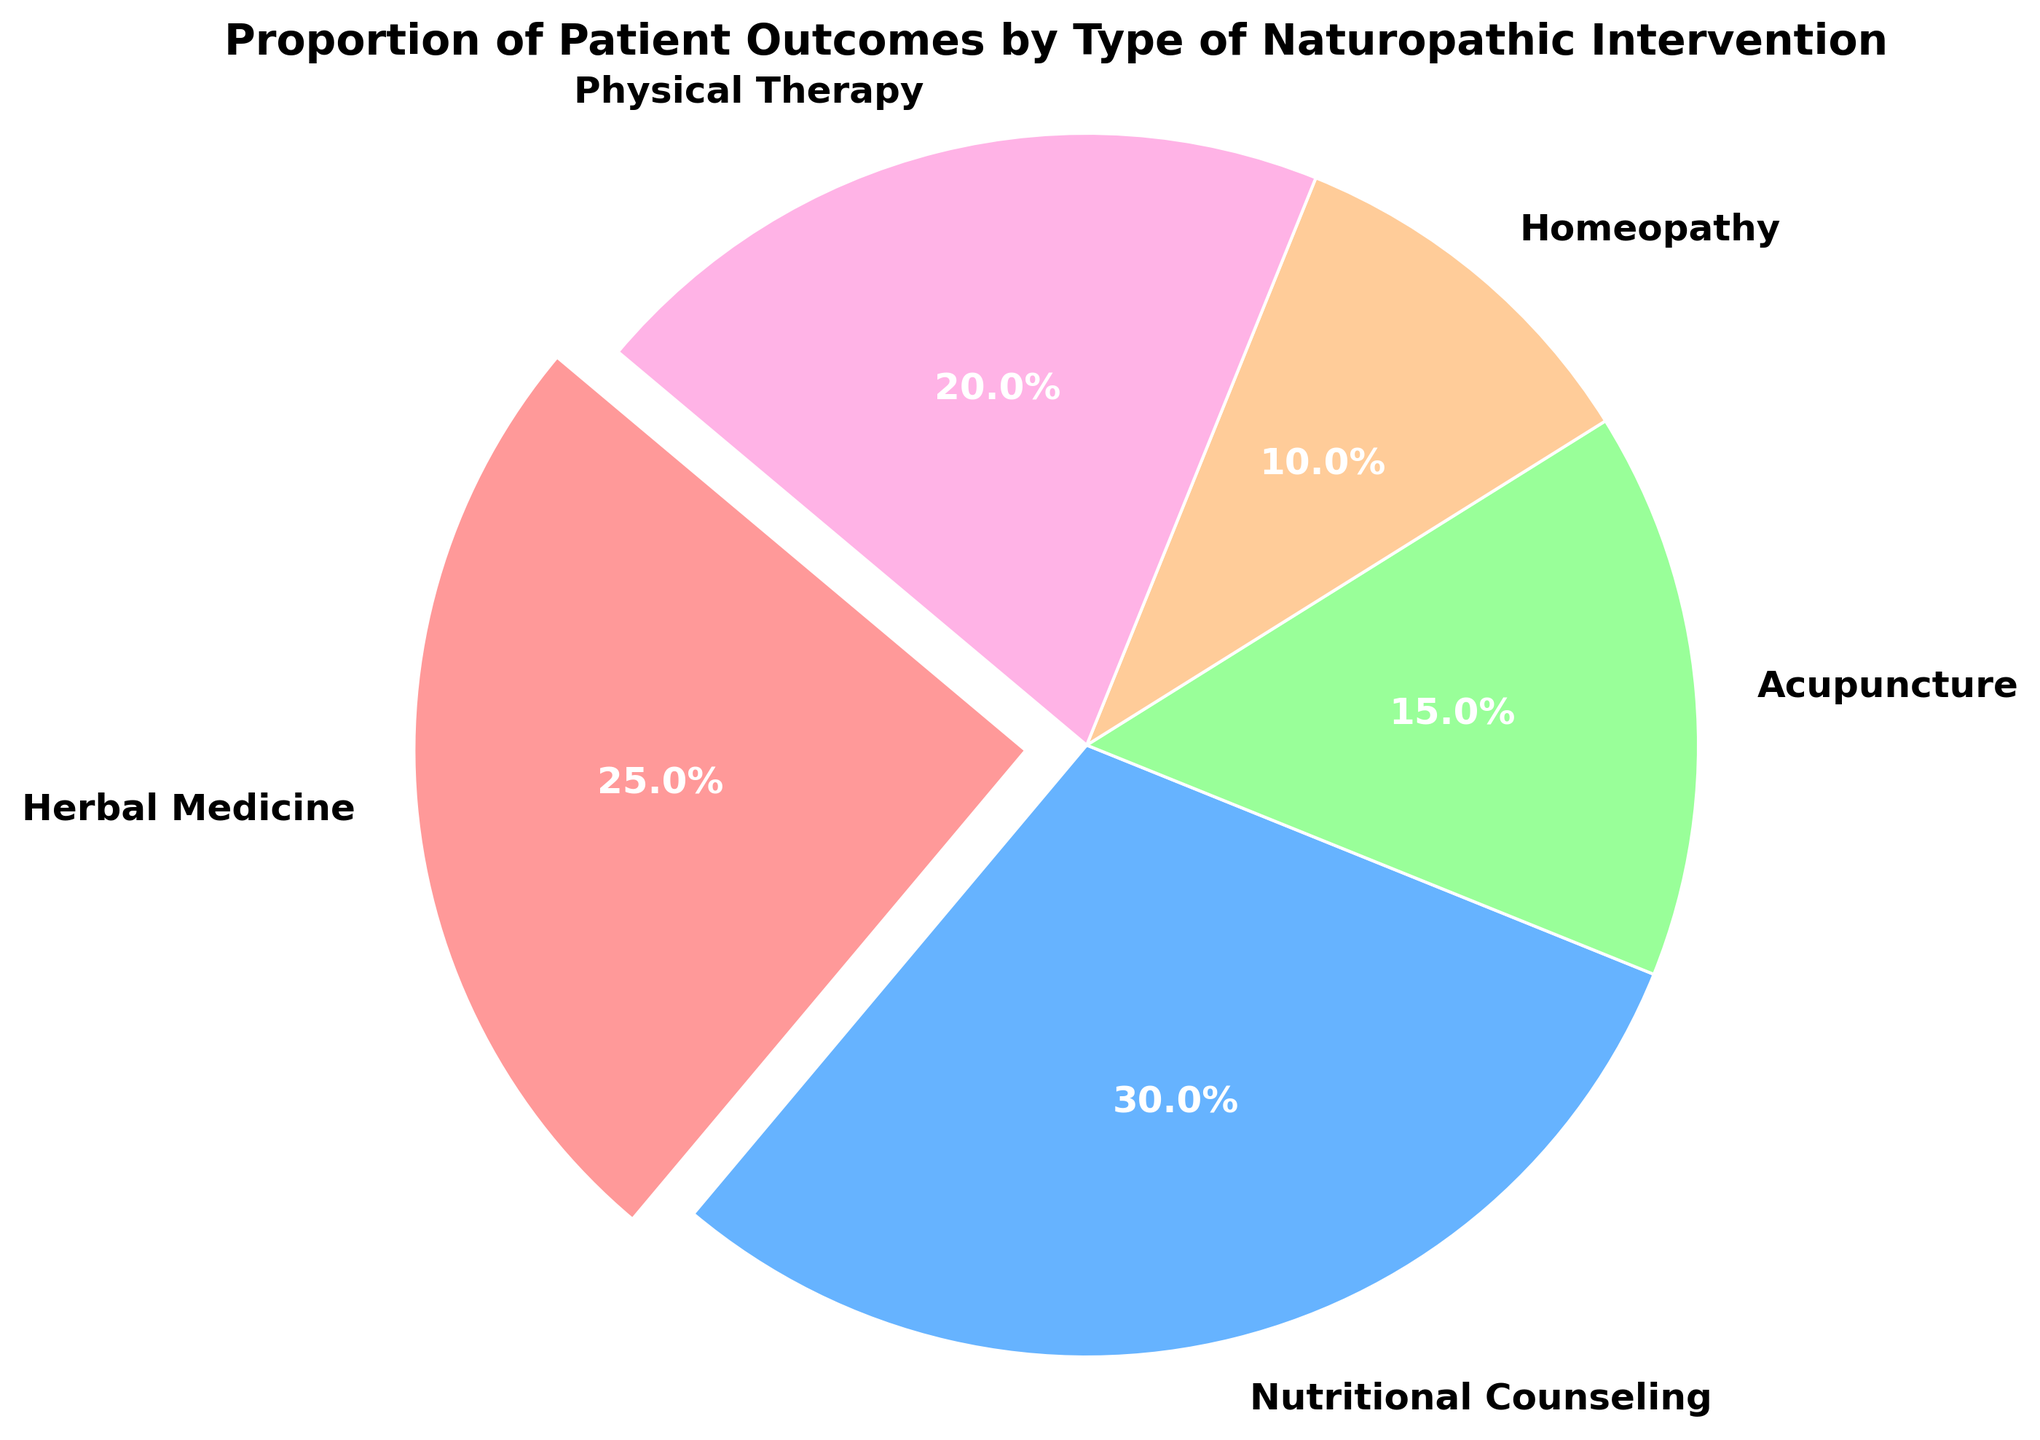What percentage of patient outcomes is attributed to Herbal Medicine? The pie chart shows the proportion of patient outcomes for different interventions, with Herbal Medicine being one of them. By looking at the chart segment labeled Herbal Medicine, we can see its percentage.
Answer: 25% Which intervention has the highest proportion of patient outcomes? The largest segment in the pie chart indicates the intervention with the highest proportion. Nutritional Counseling covers the most area in the chart.
Answer: Nutritional Counseling What is the combined proportion of patient outcomes for Acupuncture and Homeopathy? First, identify the proportions for Acupuncture and Homeopathy from the chart, which are 15% and 10%, respectively. Then, add these two proportions together (15% + 10%).
Answer: 25% Which intervention has a greater proportion of patient outcomes, Physical Therapy or Homeopathy? Compare the size of the segments for Physical Therapy and Homeopathy in the pie chart. Physical Therapy represents a larger segment than Homeopathy.
Answer: Physical Therapy What is the difference in the proportion of patient outcomes between Nutritional Counseling and Herbal Medicine? Identify the proportions for Nutritional Counseling and Herbal Medicine, which are 30% and 25%, respectively. Then, subtract the proportion of Herbal Medicine from that of Nutritional Counseling (30% - 25%).
Answer: 5% How much larger is the proportion of outcomes for Nutritional Counseling compared to Acupuncture? Identify the proportions for Nutritional Counseling (30%) and Acupuncture (15%). Subtract the proportion of Acupuncture from that of Nutritional Counseling (30% - 15%).
Answer: 15% What is the cumulative proportion of patient outcomes for interventions other than Nutritional Counseling? Calculate the total proportion by adding all other intervention proportions: Herbal Medicine (25%), Acupuncture (15%), Homeopathy (10%), and Physical Therapy (20%). Add these amounts together (25% + 15% + 10% + 20%).
Answer: 70% Which intervention has the smallest proportion of patient outcomes? Look for the smallest segment in the pie chart, which corresponds to the intervention with the lowest proportion. Homeopathy has the smallest segment.
Answer: Homeopathy What proportion of patient outcomes is attributed to interventions involving physical techniques (Physical Therapy and Acupuncture)? Identify the proportions for Physical Therapy (20%) and Acupuncture (15%). Add these two proportions together (20% + 15%).
Answer: 35% 